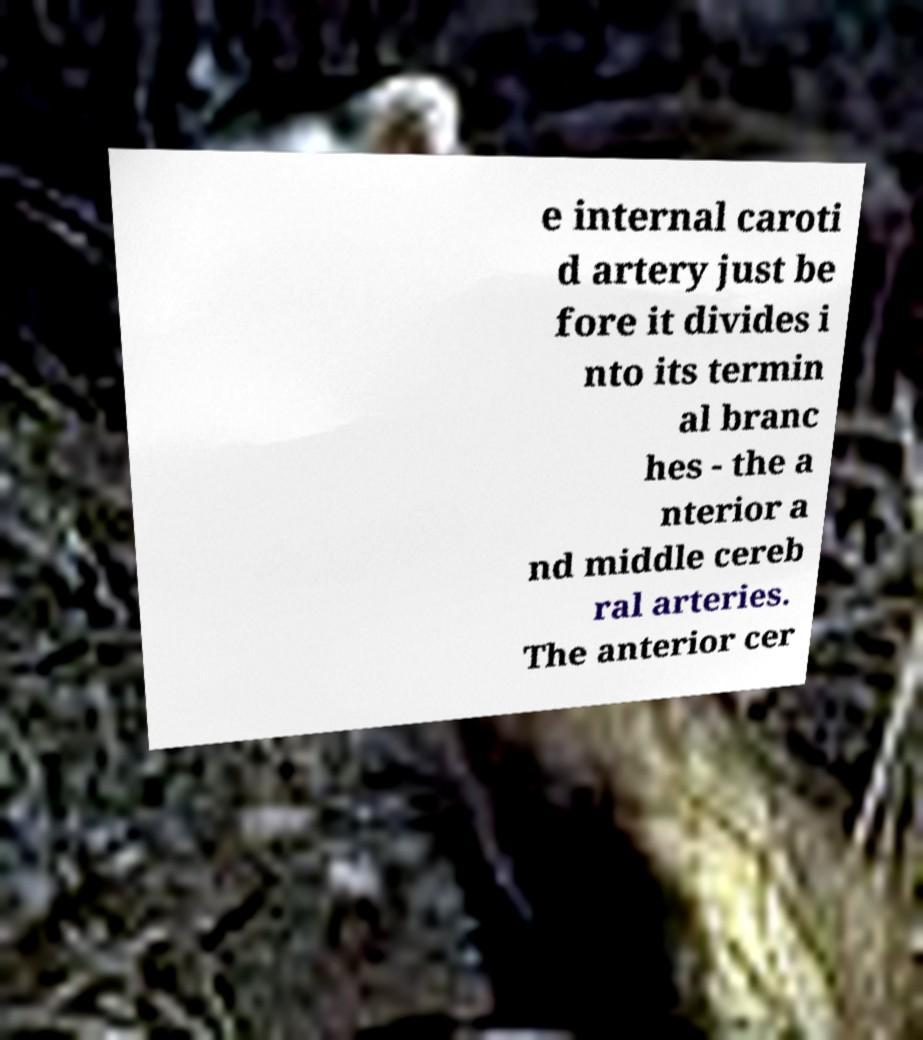Could you extract and type out the text from this image? e internal caroti d artery just be fore it divides i nto its termin al branc hes - the a nterior a nd middle cereb ral arteries. The anterior cer 